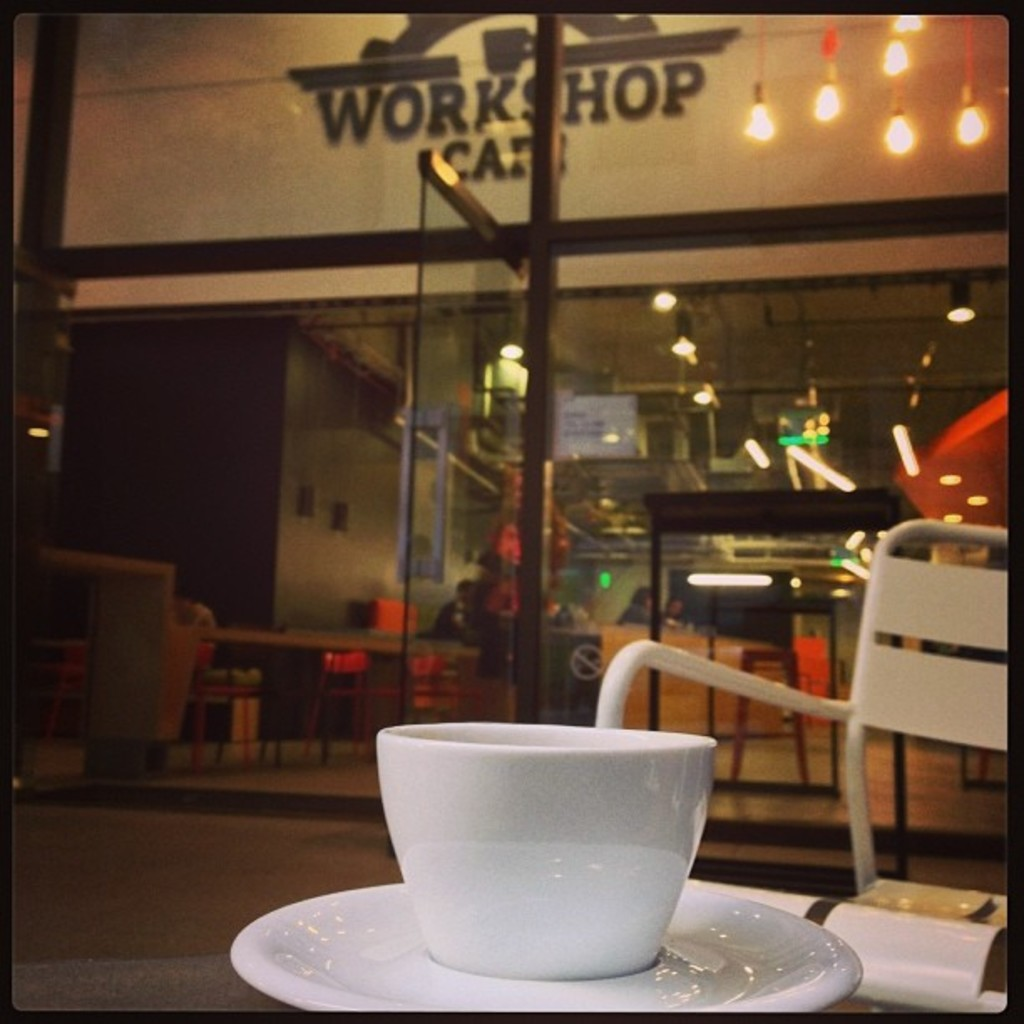Provide a one-sentence caption for the provided image. A solitary white cup sits on a sleek, white saucer on a table, offering a moment of calm against a busy backdrop of the bustling 'Workshop Cafe' engraved with vibrant lighting and visible through the glass facade. 